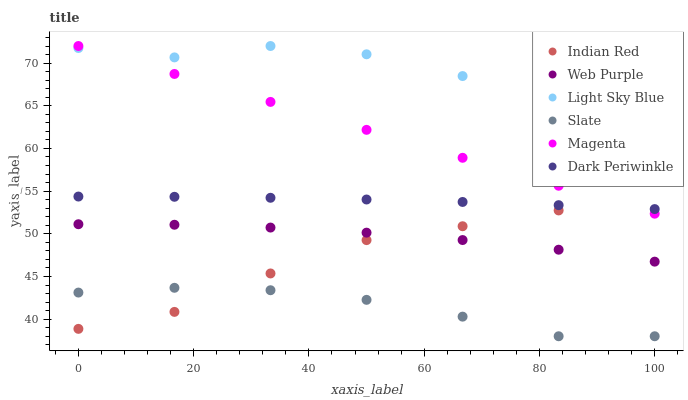Does Slate have the minimum area under the curve?
Answer yes or no. Yes. Does Light Sky Blue have the maximum area under the curve?
Answer yes or no. Yes. Does Web Purple have the minimum area under the curve?
Answer yes or no. No. Does Web Purple have the maximum area under the curve?
Answer yes or no. No. Is Magenta the smoothest?
Answer yes or no. Yes. Is Light Sky Blue the roughest?
Answer yes or no. Yes. Is Web Purple the smoothest?
Answer yes or no. No. Is Web Purple the roughest?
Answer yes or no. No. Does Slate have the lowest value?
Answer yes or no. Yes. Does Web Purple have the lowest value?
Answer yes or no. No. Does Magenta have the highest value?
Answer yes or no. Yes. Does Web Purple have the highest value?
Answer yes or no. No. Is Web Purple less than Magenta?
Answer yes or no. Yes. Is Light Sky Blue greater than Web Purple?
Answer yes or no. Yes. Does Dark Periwinkle intersect Indian Red?
Answer yes or no. Yes. Is Dark Periwinkle less than Indian Red?
Answer yes or no. No. Is Dark Periwinkle greater than Indian Red?
Answer yes or no. No. Does Web Purple intersect Magenta?
Answer yes or no. No. 